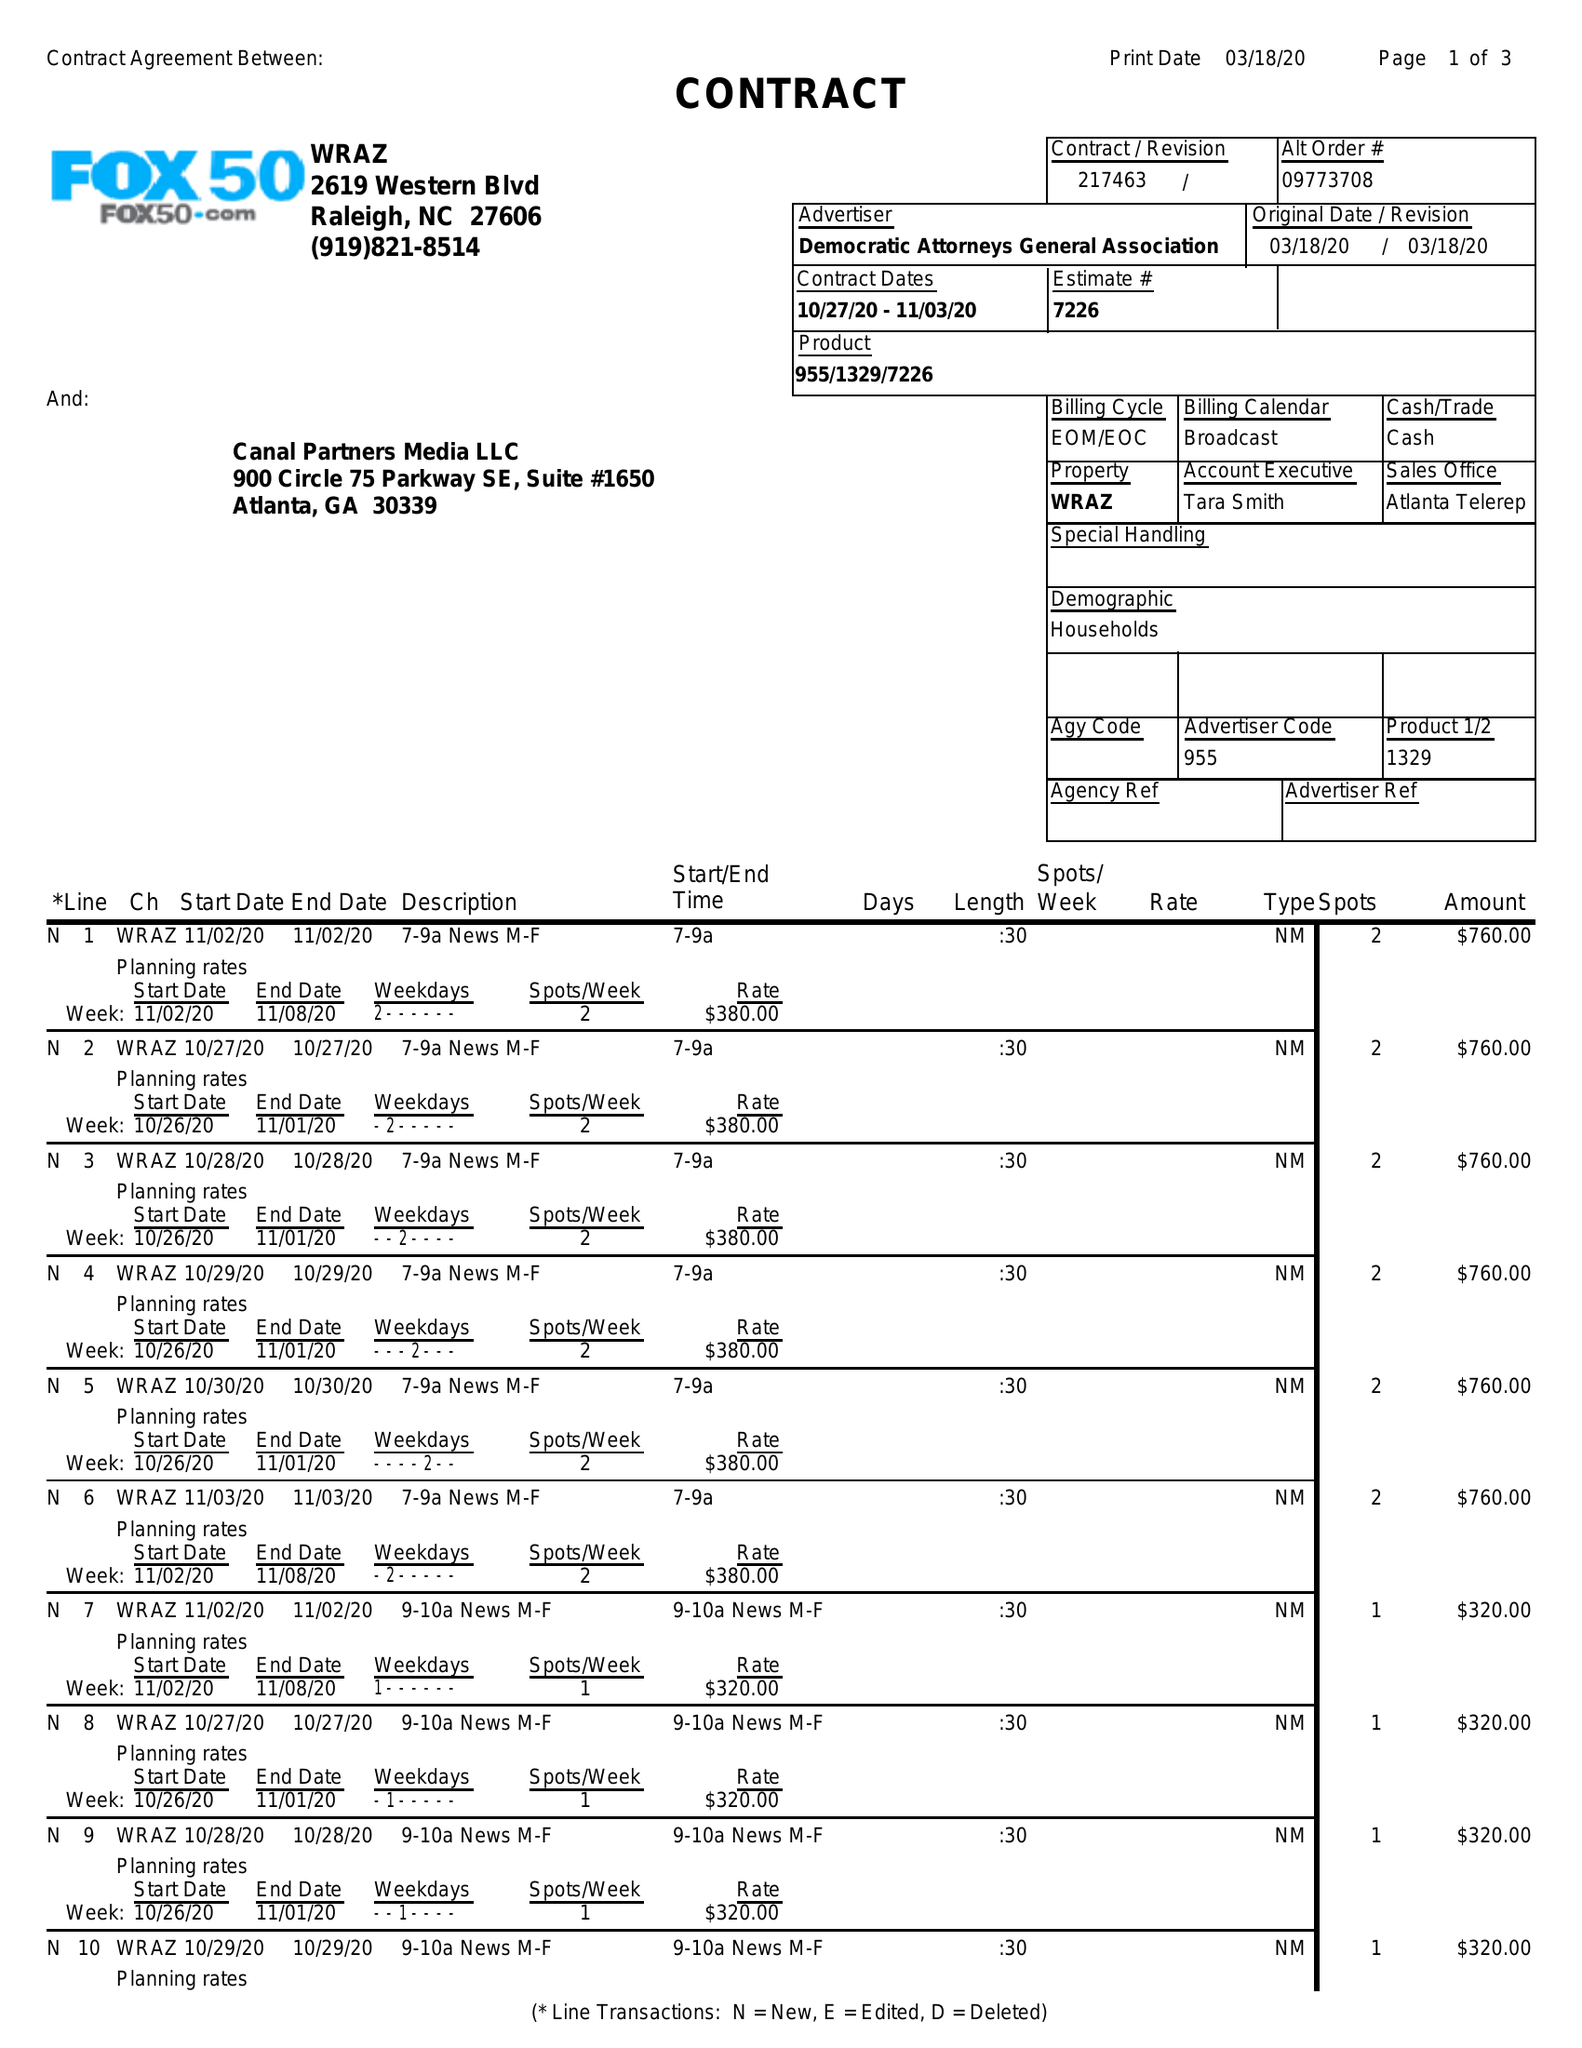What is the value for the flight_from?
Answer the question using a single word or phrase. 10/27/20 